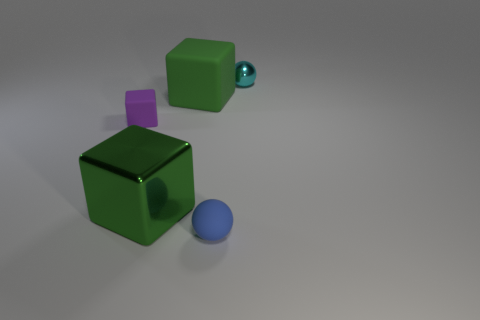Subtract 1 cubes. How many cubes are left? 2 Subtract all rubber blocks. How many blocks are left? 1 Add 2 small yellow matte objects. How many objects exist? 7 Subtract all green blocks. Subtract all cyan cylinders. How many blocks are left? 1 Subtract all blocks. How many objects are left? 2 Add 3 tiny gray things. How many tiny gray things exist? 3 Subtract 0 red cylinders. How many objects are left? 5 Subtract all tiny purple blocks. Subtract all tiny cyan spheres. How many objects are left? 3 Add 3 green rubber cubes. How many green rubber cubes are left? 4 